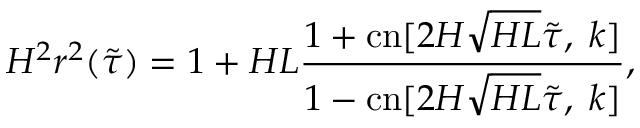Convert formula to latex. <formula><loc_0><loc_0><loc_500><loc_500>H ^ { 2 } r ^ { 2 } ( \tilde { \tau } ) = 1 + H L \frac { 1 + c n [ 2 H \sqrt { H L } \tilde { \tau } , \, k ] } { 1 - c n [ 2 H \sqrt { H L } \tilde { \tau } , \, k ] } ,</formula> 